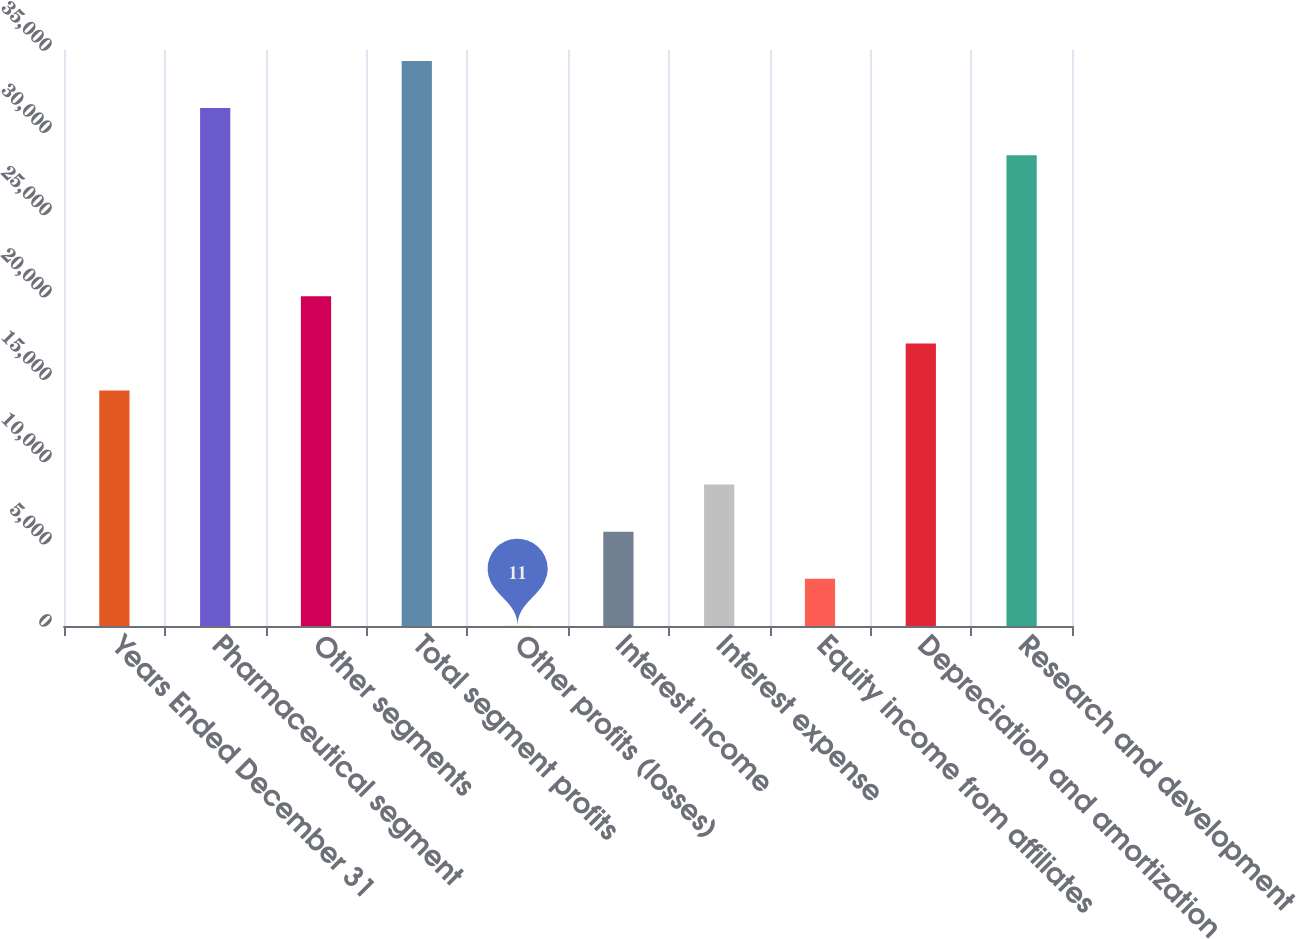Convert chart to OTSL. <chart><loc_0><loc_0><loc_500><loc_500><bar_chart><fcel>Years Ended December 31<fcel>Pharmaceutical segment<fcel>Other segments<fcel>Total segment profits<fcel>Other profits (losses)<fcel>Interest income<fcel>Interest expense<fcel>Equity income from affiliates<fcel>Depreciation and amortization<fcel>Research and development<nl><fcel>14311.5<fcel>31472.1<fcel>20031.7<fcel>34332.2<fcel>11<fcel>5731.2<fcel>8591.3<fcel>2871.1<fcel>17171.6<fcel>28612<nl></chart> 